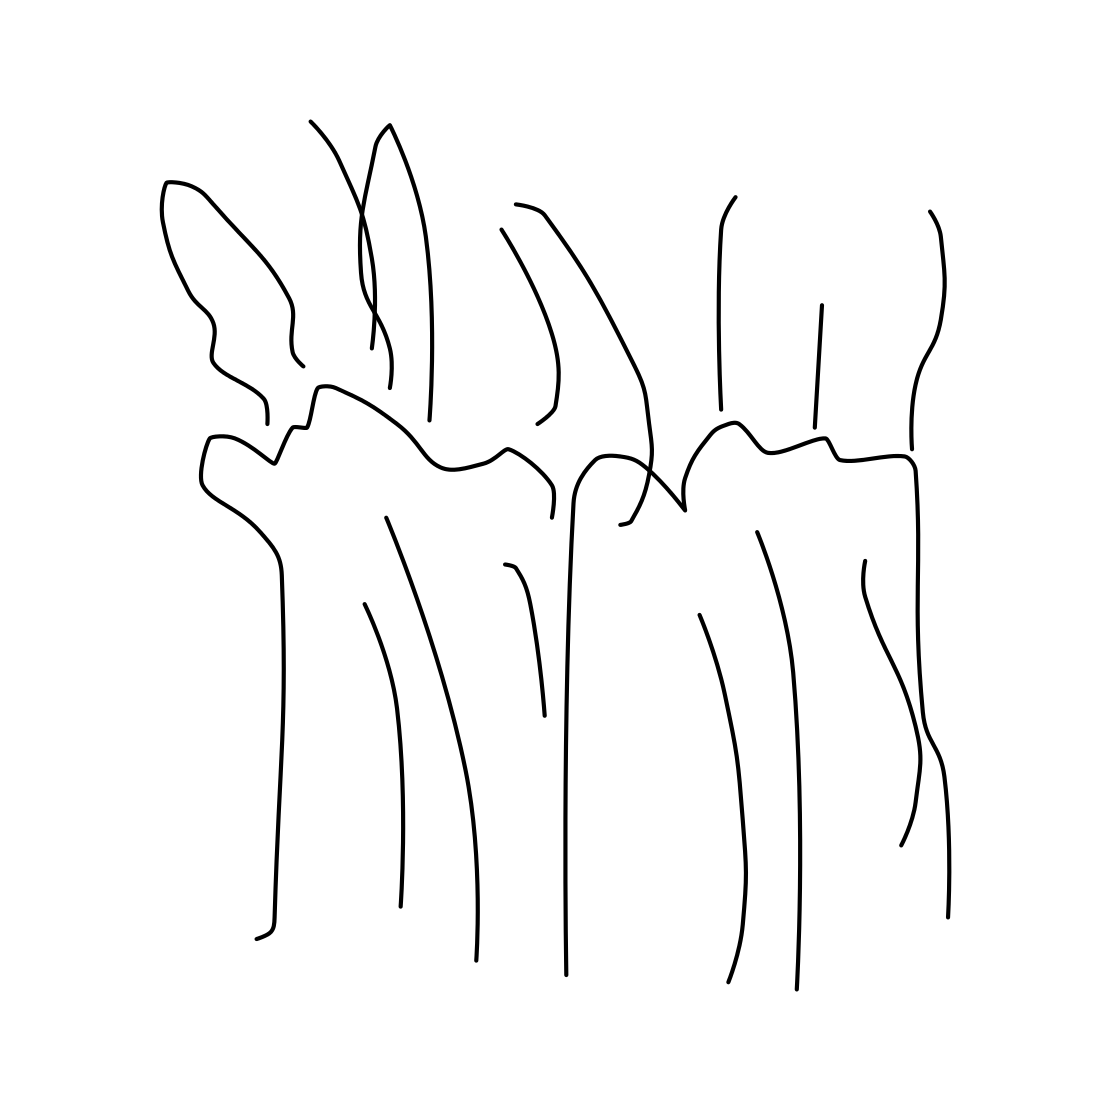In the scene, is an armchair in it? No 